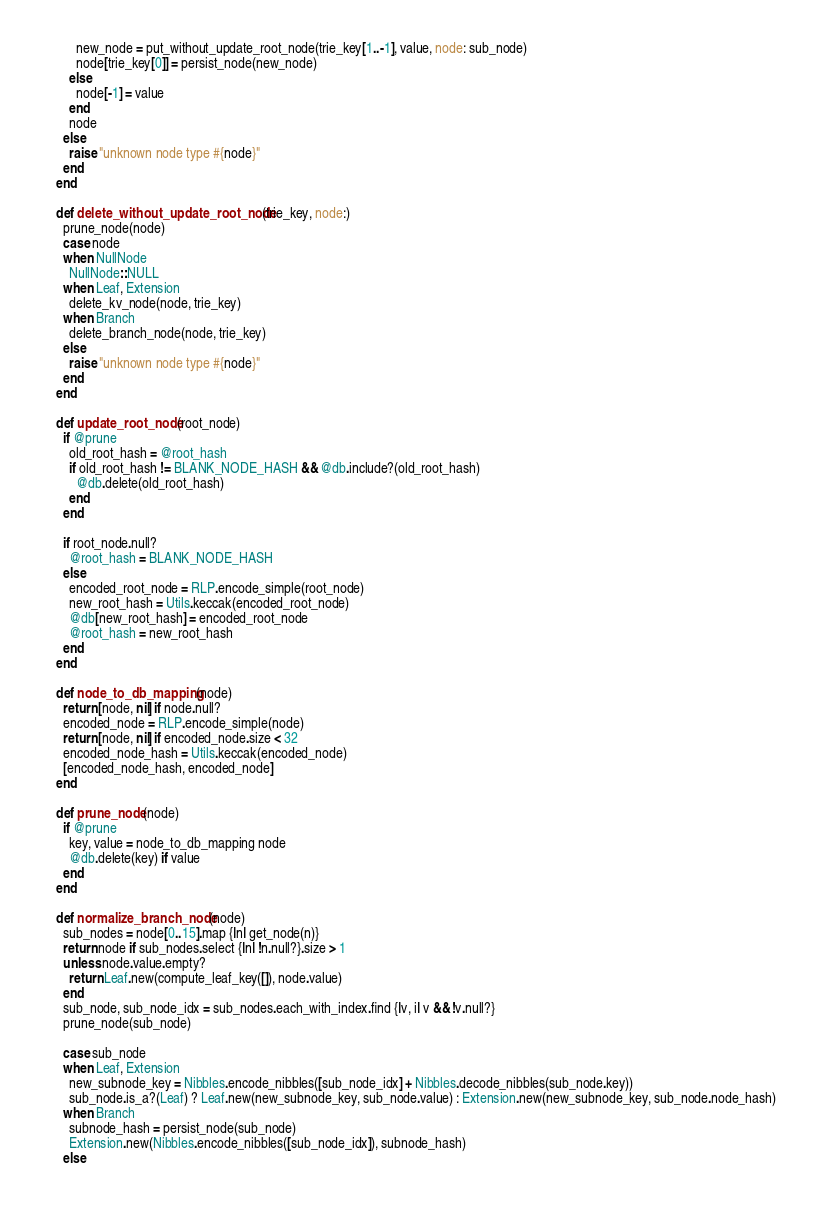Convert code to text. <code><loc_0><loc_0><loc_500><loc_500><_Ruby_>          new_node = put_without_update_root_node(trie_key[1..-1], value, node: sub_node)
          node[trie_key[0]] = persist_node(new_node)
        else
          node[-1] = value
        end
        node
      else
        raise "unknown node type #{node}"
      end
    end

    def delete_without_update_root_node(trie_key, node:)
      prune_node(node)
      case node
      when NullNode
        NullNode::NULL
      when Leaf, Extension
        delete_kv_node(node, trie_key)
      when Branch
        delete_branch_node(node, trie_key)
      else
        raise "unknown node type #{node}"
      end
    end

    def update_root_node(root_node)
      if @prune
        old_root_hash = @root_hash
        if old_root_hash != BLANK_NODE_HASH && @db.include?(old_root_hash)
          @db.delete(old_root_hash)
        end
      end

      if root_node.null?
        @root_hash = BLANK_NODE_HASH
      else
        encoded_root_node = RLP.encode_simple(root_node)
        new_root_hash = Utils.keccak(encoded_root_node)
        @db[new_root_hash] = encoded_root_node
        @root_hash = new_root_hash
      end
    end

    def node_to_db_mapping(node)
      return [node, nil] if node.null?
      encoded_node = RLP.encode_simple(node)
      return [node, nil] if encoded_node.size < 32
      encoded_node_hash = Utils.keccak(encoded_node)
      [encoded_node_hash, encoded_node]
    end

    def prune_node(node)
      if @prune
        key, value = node_to_db_mapping node
        @db.delete(key) if value
      end
    end

    def normalize_branch_node(node)
      sub_nodes = node[0..15].map {|n| get_node(n)}
      return node if sub_nodes.select {|n| !n.null?}.size > 1
      unless node.value.empty?
        return Leaf.new(compute_leaf_key([]), node.value)
      end
      sub_node, sub_node_idx = sub_nodes.each_with_index.find {|v, i| v && !v.null?}
      prune_node(sub_node)

      case sub_node
      when Leaf, Extension
        new_subnode_key = Nibbles.encode_nibbles([sub_node_idx] + Nibbles.decode_nibbles(sub_node.key))
        sub_node.is_a?(Leaf) ? Leaf.new(new_subnode_key, sub_node.value) : Extension.new(new_subnode_key, sub_node.node_hash)
      when Branch
        subnode_hash = persist_node(sub_node)
        Extension.new(Nibbles.encode_nibbles([sub_node_idx]), subnode_hash)
      else</code> 